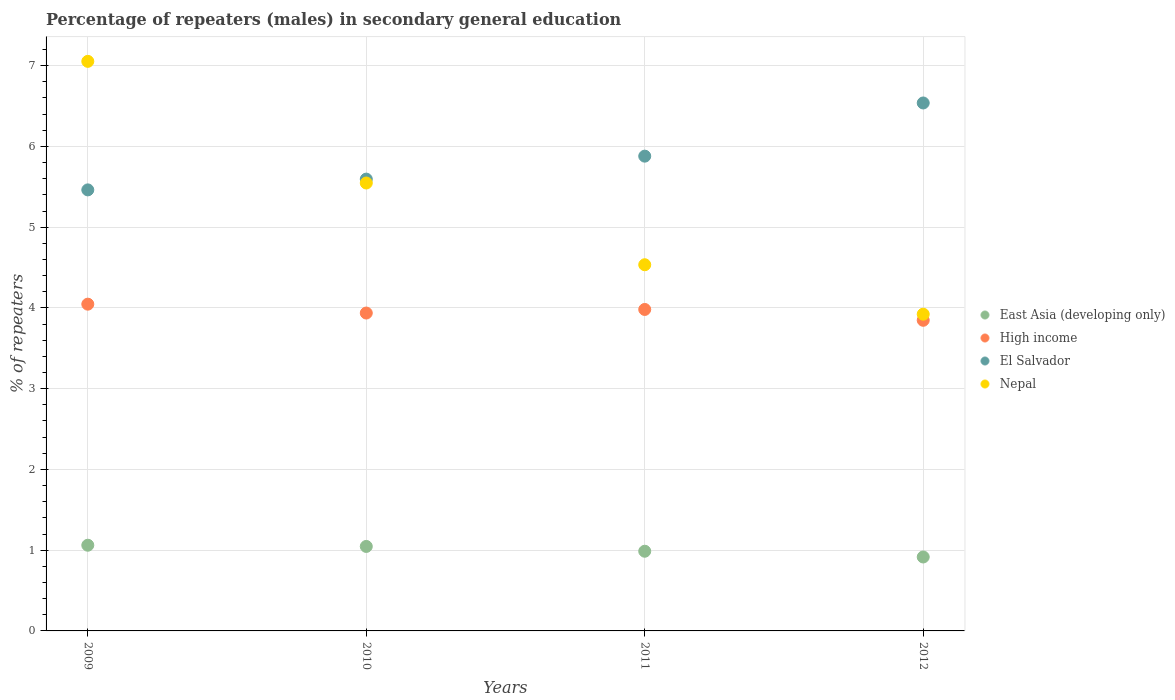Is the number of dotlines equal to the number of legend labels?
Your answer should be very brief. Yes. What is the percentage of male repeaters in East Asia (developing only) in 2011?
Your answer should be compact. 0.99. Across all years, what is the maximum percentage of male repeaters in Nepal?
Give a very brief answer. 7.05. Across all years, what is the minimum percentage of male repeaters in High income?
Offer a terse response. 3.85. In which year was the percentage of male repeaters in Nepal minimum?
Keep it short and to the point. 2012. What is the total percentage of male repeaters in East Asia (developing only) in the graph?
Your response must be concise. 4.01. What is the difference between the percentage of male repeaters in Nepal in 2009 and that in 2010?
Offer a terse response. 1.51. What is the difference between the percentage of male repeaters in East Asia (developing only) in 2011 and the percentage of male repeaters in High income in 2010?
Your answer should be very brief. -2.95. What is the average percentage of male repeaters in Nepal per year?
Ensure brevity in your answer.  5.26. In the year 2010, what is the difference between the percentage of male repeaters in Nepal and percentage of male repeaters in East Asia (developing only)?
Ensure brevity in your answer.  4.5. In how many years, is the percentage of male repeaters in High income greater than 1.2 %?
Offer a terse response. 4. What is the ratio of the percentage of male repeaters in Nepal in 2009 to that in 2010?
Offer a very short reply. 1.27. What is the difference between the highest and the second highest percentage of male repeaters in East Asia (developing only)?
Your response must be concise. 0.02. What is the difference between the highest and the lowest percentage of male repeaters in East Asia (developing only)?
Your response must be concise. 0.15. In how many years, is the percentage of male repeaters in Nepal greater than the average percentage of male repeaters in Nepal taken over all years?
Give a very brief answer. 2. Is it the case that in every year, the sum of the percentage of male repeaters in High income and percentage of male repeaters in El Salvador  is greater than the sum of percentage of male repeaters in Nepal and percentage of male repeaters in East Asia (developing only)?
Make the answer very short. Yes. Does the percentage of male repeaters in High income monotonically increase over the years?
Your answer should be very brief. No. Is the percentage of male repeaters in Nepal strictly greater than the percentage of male repeaters in East Asia (developing only) over the years?
Your response must be concise. Yes. Is the percentage of male repeaters in High income strictly less than the percentage of male repeaters in Nepal over the years?
Provide a succinct answer. Yes. How many dotlines are there?
Provide a short and direct response. 4. How many years are there in the graph?
Offer a very short reply. 4. What is the difference between two consecutive major ticks on the Y-axis?
Offer a terse response. 1. Are the values on the major ticks of Y-axis written in scientific E-notation?
Your answer should be very brief. No. Does the graph contain grids?
Ensure brevity in your answer.  Yes. Where does the legend appear in the graph?
Keep it short and to the point. Center right. How are the legend labels stacked?
Offer a very short reply. Vertical. What is the title of the graph?
Provide a short and direct response. Percentage of repeaters (males) in secondary general education. Does "Tanzania" appear as one of the legend labels in the graph?
Your answer should be very brief. No. What is the label or title of the X-axis?
Ensure brevity in your answer.  Years. What is the label or title of the Y-axis?
Make the answer very short. % of repeaters. What is the % of repeaters of East Asia (developing only) in 2009?
Make the answer very short. 1.06. What is the % of repeaters in High income in 2009?
Provide a succinct answer. 4.05. What is the % of repeaters in El Salvador in 2009?
Your answer should be compact. 5.46. What is the % of repeaters of Nepal in 2009?
Your answer should be very brief. 7.05. What is the % of repeaters in East Asia (developing only) in 2010?
Your answer should be compact. 1.05. What is the % of repeaters in High income in 2010?
Provide a succinct answer. 3.94. What is the % of repeaters in El Salvador in 2010?
Keep it short and to the point. 5.6. What is the % of repeaters of Nepal in 2010?
Offer a very short reply. 5.55. What is the % of repeaters in East Asia (developing only) in 2011?
Provide a succinct answer. 0.99. What is the % of repeaters of High income in 2011?
Your answer should be compact. 3.98. What is the % of repeaters in El Salvador in 2011?
Your response must be concise. 5.88. What is the % of repeaters in Nepal in 2011?
Make the answer very short. 4.53. What is the % of repeaters in East Asia (developing only) in 2012?
Make the answer very short. 0.92. What is the % of repeaters of High income in 2012?
Your response must be concise. 3.85. What is the % of repeaters of El Salvador in 2012?
Ensure brevity in your answer.  6.54. What is the % of repeaters of Nepal in 2012?
Provide a succinct answer. 3.92. Across all years, what is the maximum % of repeaters of East Asia (developing only)?
Give a very brief answer. 1.06. Across all years, what is the maximum % of repeaters of High income?
Make the answer very short. 4.05. Across all years, what is the maximum % of repeaters in El Salvador?
Provide a short and direct response. 6.54. Across all years, what is the maximum % of repeaters in Nepal?
Keep it short and to the point. 7.05. Across all years, what is the minimum % of repeaters of East Asia (developing only)?
Offer a terse response. 0.92. Across all years, what is the minimum % of repeaters in High income?
Provide a succinct answer. 3.85. Across all years, what is the minimum % of repeaters in El Salvador?
Provide a short and direct response. 5.46. Across all years, what is the minimum % of repeaters in Nepal?
Keep it short and to the point. 3.92. What is the total % of repeaters in East Asia (developing only) in the graph?
Offer a very short reply. 4.01. What is the total % of repeaters of High income in the graph?
Ensure brevity in your answer.  15.81. What is the total % of repeaters in El Salvador in the graph?
Give a very brief answer. 23.48. What is the total % of repeaters in Nepal in the graph?
Offer a terse response. 21.06. What is the difference between the % of repeaters of East Asia (developing only) in 2009 and that in 2010?
Ensure brevity in your answer.  0.01. What is the difference between the % of repeaters of High income in 2009 and that in 2010?
Offer a very short reply. 0.11. What is the difference between the % of repeaters of El Salvador in 2009 and that in 2010?
Ensure brevity in your answer.  -0.13. What is the difference between the % of repeaters of Nepal in 2009 and that in 2010?
Ensure brevity in your answer.  1.51. What is the difference between the % of repeaters in East Asia (developing only) in 2009 and that in 2011?
Your answer should be very brief. 0.07. What is the difference between the % of repeaters of High income in 2009 and that in 2011?
Give a very brief answer. 0.07. What is the difference between the % of repeaters in El Salvador in 2009 and that in 2011?
Give a very brief answer. -0.42. What is the difference between the % of repeaters in Nepal in 2009 and that in 2011?
Your answer should be very brief. 2.52. What is the difference between the % of repeaters in East Asia (developing only) in 2009 and that in 2012?
Provide a succinct answer. 0.15. What is the difference between the % of repeaters of High income in 2009 and that in 2012?
Your response must be concise. 0.2. What is the difference between the % of repeaters of El Salvador in 2009 and that in 2012?
Ensure brevity in your answer.  -1.08. What is the difference between the % of repeaters in Nepal in 2009 and that in 2012?
Offer a very short reply. 3.13. What is the difference between the % of repeaters of East Asia (developing only) in 2010 and that in 2011?
Provide a succinct answer. 0.06. What is the difference between the % of repeaters in High income in 2010 and that in 2011?
Offer a very short reply. -0.04. What is the difference between the % of repeaters in El Salvador in 2010 and that in 2011?
Ensure brevity in your answer.  -0.28. What is the difference between the % of repeaters of Nepal in 2010 and that in 2011?
Offer a terse response. 1.01. What is the difference between the % of repeaters of East Asia (developing only) in 2010 and that in 2012?
Your answer should be very brief. 0.13. What is the difference between the % of repeaters in High income in 2010 and that in 2012?
Your response must be concise. 0.09. What is the difference between the % of repeaters of El Salvador in 2010 and that in 2012?
Your answer should be very brief. -0.94. What is the difference between the % of repeaters of Nepal in 2010 and that in 2012?
Your answer should be compact. 1.62. What is the difference between the % of repeaters of East Asia (developing only) in 2011 and that in 2012?
Provide a short and direct response. 0.07. What is the difference between the % of repeaters of High income in 2011 and that in 2012?
Ensure brevity in your answer.  0.13. What is the difference between the % of repeaters in El Salvador in 2011 and that in 2012?
Provide a succinct answer. -0.66. What is the difference between the % of repeaters of Nepal in 2011 and that in 2012?
Make the answer very short. 0.61. What is the difference between the % of repeaters in East Asia (developing only) in 2009 and the % of repeaters in High income in 2010?
Provide a short and direct response. -2.88. What is the difference between the % of repeaters in East Asia (developing only) in 2009 and the % of repeaters in El Salvador in 2010?
Your answer should be compact. -4.53. What is the difference between the % of repeaters in East Asia (developing only) in 2009 and the % of repeaters in Nepal in 2010?
Make the answer very short. -4.49. What is the difference between the % of repeaters in High income in 2009 and the % of repeaters in El Salvador in 2010?
Provide a short and direct response. -1.55. What is the difference between the % of repeaters in High income in 2009 and the % of repeaters in Nepal in 2010?
Provide a short and direct response. -1.5. What is the difference between the % of repeaters of El Salvador in 2009 and the % of repeaters of Nepal in 2010?
Your answer should be very brief. -0.09. What is the difference between the % of repeaters of East Asia (developing only) in 2009 and the % of repeaters of High income in 2011?
Offer a terse response. -2.92. What is the difference between the % of repeaters of East Asia (developing only) in 2009 and the % of repeaters of El Salvador in 2011?
Make the answer very short. -4.82. What is the difference between the % of repeaters in East Asia (developing only) in 2009 and the % of repeaters in Nepal in 2011?
Make the answer very short. -3.47. What is the difference between the % of repeaters in High income in 2009 and the % of repeaters in El Salvador in 2011?
Provide a short and direct response. -1.83. What is the difference between the % of repeaters of High income in 2009 and the % of repeaters of Nepal in 2011?
Offer a very short reply. -0.49. What is the difference between the % of repeaters of El Salvador in 2009 and the % of repeaters of Nepal in 2011?
Offer a terse response. 0.93. What is the difference between the % of repeaters in East Asia (developing only) in 2009 and the % of repeaters in High income in 2012?
Keep it short and to the point. -2.79. What is the difference between the % of repeaters in East Asia (developing only) in 2009 and the % of repeaters in El Salvador in 2012?
Provide a short and direct response. -5.48. What is the difference between the % of repeaters in East Asia (developing only) in 2009 and the % of repeaters in Nepal in 2012?
Make the answer very short. -2.86. What is the difference between the % of repeaters of High income in 2009 and the % of repeaters of El Salvador in 2012?
Give a very brief answer. -2.49. What is the difference between the % of repeaters of High income in 2009 and the % of repeaters of Nepal in 2012?
Your answer should be very brief. 0.12. What is the difference between the % of repeaters in El Salvador in 2009 and the % of repeaters in Nepal in 2012?
Offer a very short reply. 1.54. What is the difference between the % of repeaters in East Asia (developing only) in 2010 and the % of repeaters in High income in 2011?
Your answer should be compact. -2.93. What is the difference between the % of repeaters in East Asia (developing only) in 2010 and the % of repeaters in El Salvador in 2011?
Keep it short and to the point. -4.83. What is the difference between the % of repeaters in East Asia (developing only) in 2010 and the % of repeaters in Nepal in 2011?
Provide a succinct answer. -3.49. What is the difference between the % of repeaters in High income in 2010 and the % of repeaters in El Salvador in 2011?
Offer a terse response. -1.94. What is the difference between the % of repeaters in High income in 2010 and the % of repeaters in Nepal in 2011?
Offer a very short reply. -0.6. What is the difference between the % of repeaters in El Salvador in 2010 and the % of repeaters in Nepal in 2011?
Ensure brevity in your answer.  1.06. What is the difference between the % of repeaters of East Asia (developing only) in 2010 and the % of repeaters of High income in 2012?
Your answer should be very brief. -2.8. What is the difference between the % of repeaters in East Asia (developing only) in 2010 and the % of repeaters in El Salvador in 2012?
Provide a short and direct response. -5.49. What is the difference between the % of repeaters in East Asia (developing only) in 2010 and the % of repeaters in Nepal in 2012?
Keep it short and to the point. -2.88. What is the difference between the % of repeaters of High income in 2010 and the % of repeaters of El Salvador in 2012?
Provide a short and direct response. -2.6. What is the difference between the % of repeaters of High income in 2010 and the % of repeaters of Nepal in 2012?
Keep it short and to the point. 0.01. What is the difference between the % of repeaters of El Salvador in 2010 and the % of repeaters of Nepal in 2012?
Ensure brevity in your answer.  1.67. What is the difference between the % of repeaters of East Asia (developing only) in 2011 and the % of repeaters of High income in 2012?
Offer a terse response. -2.86. What is the difference between the % of repeaters of East Asia (developing only) in 2011 and the % of repeaters of El Salvador in 2012?
Give a very brief answer. -5.55. What is the difference between the % of repeaters of East Asia (developing only) in 2011 and the % of repeaters of Nepal in 2012?
Give a very brief answer. -2.94. What is the difference between the % of repeaters in High income in 2011 and the % of repeaters in El Salvador in 2012?
Your response must be concise. -2.56. What is the difference between the % of repeaters of High income in 2011 and the % of repeaters of Nepal in 2012?
Offer a very short reply. 0.06. What is the difference between the % of repeaters in El Salvador in 2011 and the % of repeaters in Nepal in 2012?
Offer a terse response. 1.96. What is the average % of repeaters in East Asia (developing only) per year?
Provide a succinct answer. 1. What is the average % of repeaters in High income per year?
Make the answer very short. 3.95. What is the average % of repeaters of El Salvador per year?
Make the answer very short. 5.87. What is the average % of repeaters of Nepal per year?
Your answer should be very brief. 5.26. In the year 2009, what is the difference between the % of repeaters of East Asia (developing only) and % of repeaters of High income?
Offer a very short reply. -2.99. In the year 2009, what is the difference between the % of repeaters of East Asia (developing only) and % of repeaters of El Salvador?
Ensure brevity in your answer.  -4.4. In the year 2009, what is the difference between the % of repeaters in East Asia (developing only) and % of repeaters in Nepal?
Your answer should be compact. -5.99. In the year 2009, what is the difference between the % of repeaters in High income and % of repeaters in El Salvador?
Keep it short and to the point. -1.42. In the year 2009, what is the difference between the % of repeaters of High income and % of repeaters of Nepal?
Your response must be concise. -3.01. In the year 2009, what is the difference between the % of repeaters in El Salvador and % of repeaters in Nepal?
Keep it short and to the point. -1.59. In the year 2010, what is the difference between the % of repeaters in East Asia (developing only) and % of repeaters in High income?
Your response must be concise. -2.89. In the year 2010, what is the difference between the % of repeaters of East Asia (developing only) and % of repeaters of El Salvador?
Give a very brief answer. -4.55. In the year 2010, what is the difference between the % of repeaters of East Asia (developing only) and % of repeaters of Nepal?
Provide a short and direct response. -4.5. In the year 2010, what is the difference between the % of repeaters in High income and % of repeaters in El Salvador?
Keep it short and to the point. -1.66. In the year 2010, what is the difference between the % of repeaters of High income and % of repeaters of Nepal?
Ensure brevity in your answer.  -1.61. In the year 2010, what is the difference between the % of repeaters in El Salvador and % of repeaters in Nepal?
Provide a short and direct response. 0.05. In the year 2011, what is the difference between the % of repeaters of East Asia (developing only) and % of repeaters of High income?
Your answer should be very brief. -2.99. In the year 2011, what is the difference between the % of repeaters of East Asia (developing only) and % of repeaters of El Salvador?
Make the answer very short. -4.89. In the year 2011, what is the difference between the % of repeaters of East Asia (developing only) and % of repeaters of Nepal?
Your answer should be very brief. -3.55. In the year 2011, what is the difference between the % of repeaters in High income and % of repeaters in El Salvador?
Make the answer very short. -1.9. In the year 2011, what is the difference between the % of repeaters in High income and % of repeaters in Nepal?
Offer a very short reply. -0.55. In the year 2011, what is the difference between the % of repeaters in El Salvador and % of repeaters in Nepal?
Provide a succinct answer. 1.34. In the year 2012, what is the difference between the % of repeaters in East Asia (developing only) and % of repeaters in High income?
Provide a short and direct response. -2.93. In the year 2012, what is the difference between the % of repeaters of East Asia (developing only) and % of repeaters of El Salvador?
Keep it short and to the point. -5.62. In the year 2012, what is the difference between the % of repeaters in East Asia (developing only) and % of repeaters in Nepal?
Your answer should be very brief. -3.01. In the year 2012, what is the difference between the % of repeaters of High income and % of repeaters of El Salvador?
Offer a very short reply. -2.69. In the year 2012, what is the difference between the % of repeaters of High income and % of repeaters of Nepal?
Your answer should be very brief. -0.08. In the year 2012, what is the difference between the % of repeaters of El Salvador and % of repeaters of Nepal?
Keep it short and to the point. 2.62. What is the ratio of the % of repeaters of East Asia (developing only) in 2009 to that in 2010?
Ensure brevity in your answer.  1.01. What is the ratio of the % of repeaters of High income in 2009 to that in 2010?
Ensure brevity in your answer.  1.03. What is the ratio of the % of repeaters in El Salvador in 2009 to that in 2010?
Give a very brief answer. 0.98. What is the ratio of the % of repeaters in Nepal in 2009 to that in 2010?
Make the answer very short. 1.27. What is the ratio of the % of repeaters of East Asia (developing only) in 2009 to that in 2011?
Provide a short and direct response. 1.08. What is the ratio of the % of repeaters in High income in 2009 to that in 2011?
Your answer should be compact. 1.02. What is the ratio of the % of repeaters of El Salvador in 2009 to that in 2011?
Give a very brief answer. 0.93. What is the ratio of the % of repeaters in Nepal in 2009 to that in 2011?
Provide a succinct answer. 1.56. What is the ratio of the % of repeaters in East Asia (developing only) in 2009 to that in 2012?
Your answer should be compact. 1.16. What is the ratio of the % of repeaters of High income in 2009 to that in 2012?
Keep it short and to the point. 1.05. What is the ratio of the % of repeaters in El Salvador in 2009 to that in 2012?
Give a very brief answer. 0.84. What is the ratio of the % of repeaters in Nepal in 2009 to that in 2012?
Your response must be concise. 1.8. What is the ratio of the % of repeaters in East Asia (developing only) in 2010 to that in 2011?
Make the answer very short. 1.06. What is the ratio of the % of repeaters of High income in 2010 to that in 2011?
Make the answer very short. 0.99. What is the ratio of the % of repeaters of El Salvador in 2010 to that in 2011?
Keep it short and to the point. 0.95. What is the ratio of the % of repeaters of Nepal in 2010 to that in 2011?
Offer a terse response. 1.22. What is the ratio of the % of repeaters of East Asia (developing only) in 2010 to that in 2012?
Your answer should be very brief. 1.14. What is the ratio of the % of repeaters in High income in 2010 to that in 2012?
Offer a terse response. 1.02. What is the ratio of the % of repeaters in El Salvador in 2010 to that in 2012?
Make the answer very short. 0.86. What is the ratio of the % of repeaters in Nepal in 2010 to that in 2012?
Your answer should be compact. 1.41. What is the ratio of the % of repeaters of East Asia (developing only) in 2011 to that in 2012?
Offer a terse response. 1.08. What is the ratio of the % of repeaters of High income in 2011 to that in 2012?
Keep it short and to the point. 1.03. What is the ratio of the % of repeaters in El Salvador in 2011 to that in 2012?
Offer a terse response. 0.9. What is the ratio of the % of repeaters in Nepal in 2011 to that in 2012?
Keep it short and to the point. 1.16. What is the difference between the highest and the second highest % of repeaters of East Asia (developing only)?
Your answer should be compact. 0.01. What is the difference between the highest and the second highest % of repeaters in High income?
Ensure brevity in your answer.  0.07. What is the difference between the highest and the second highest % of repeaters of El Salvador?
Your answer should be compact. 0.66. What is the difference between the highest and the second highest % of repeaters of Nepal?
Your answer should be compact. 1.51. What is the difference between the highest and the lowest % of repeaters in East Asia (developing only)?
Keep it short and to the point. 0.15. What is the difference between the highest and the lowest % of repeaters of High income?
Your response must be concise. 0.2. What is the difference between the highest and the lowest % of repeaters in El Salvador?
Make the answer very short. 1.08. What is the difference between the highest and the lowest % of repeaters of Nepal?
Your response must be concise. 3.13. 